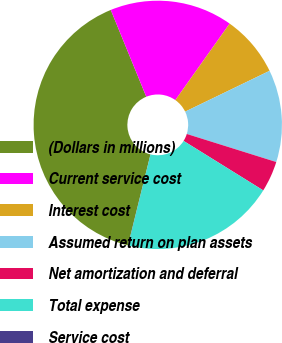<chart> <loc_0><loc_0><loc_500><loc_500><pie_chart><fcel>(Dollars in millions)<fcel>Current service cost<fcel>Interest cost<fcel>Assumed return on plan assets<fcel>Net amortization and deferral<fcel>Total expense<fcel>Service cost<nl><fcel>39.96%<fcel>16.0%<fcel>8.01%<fcel>12.0%<fcel>4.01%<fcel>19.99%<fcel>0.02%<nl></chart> 